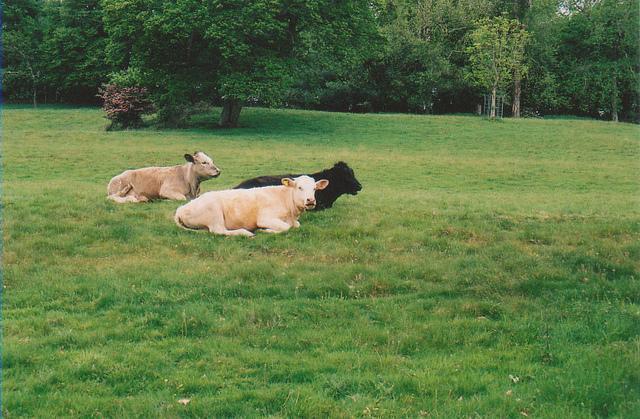What are the cows doing?
Select the correct answer and articulate reasoning with the following format: 'Answer: answer
Rationale: rationale.'
Options: Walking, laying down, playing soccer, running. Answer: laying down.
Rationale: The cows are laying down in the field of grass. 